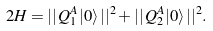Convert formula to latex. <formula><loc_0><loc_0><loc_500><loc_500>2 H = | | \, Q _ { 1 } ^ { A } | 0 \rangle \, | | ^ { 2 } + | | \, Q _ { 2 } ^ { A } | 0 \rangle \, | | ^ { 2 } .</formula> 